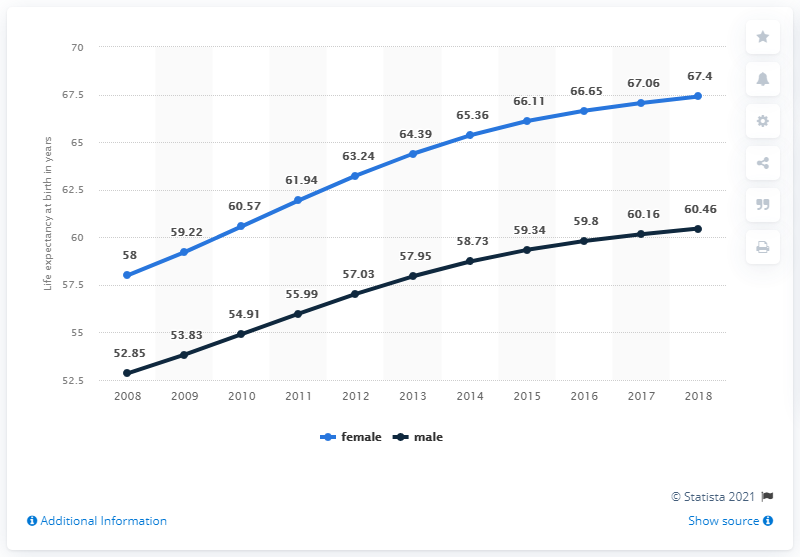List a handful of essential elements in this visual. In 2017, the average life expectancy was 63.61 years. In 2018, female life expectancy reached its peak. 